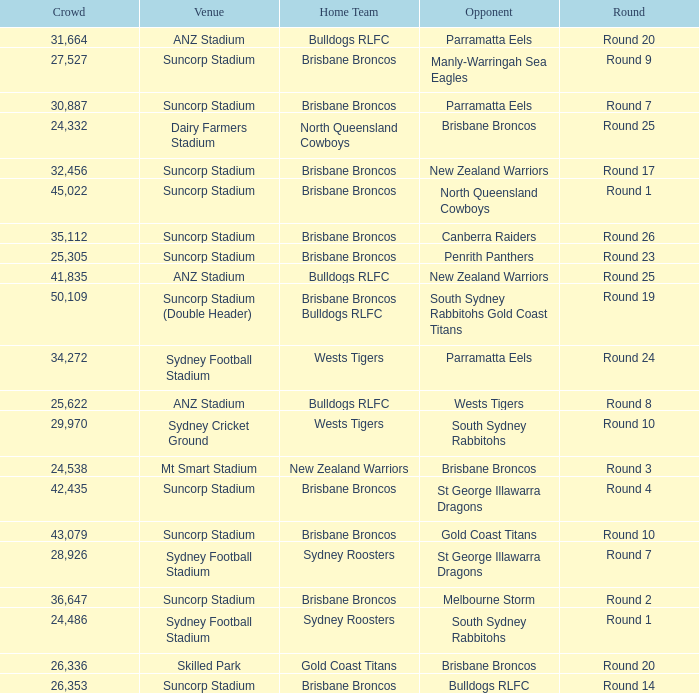What was the attendance at Round 9? 1.0. 